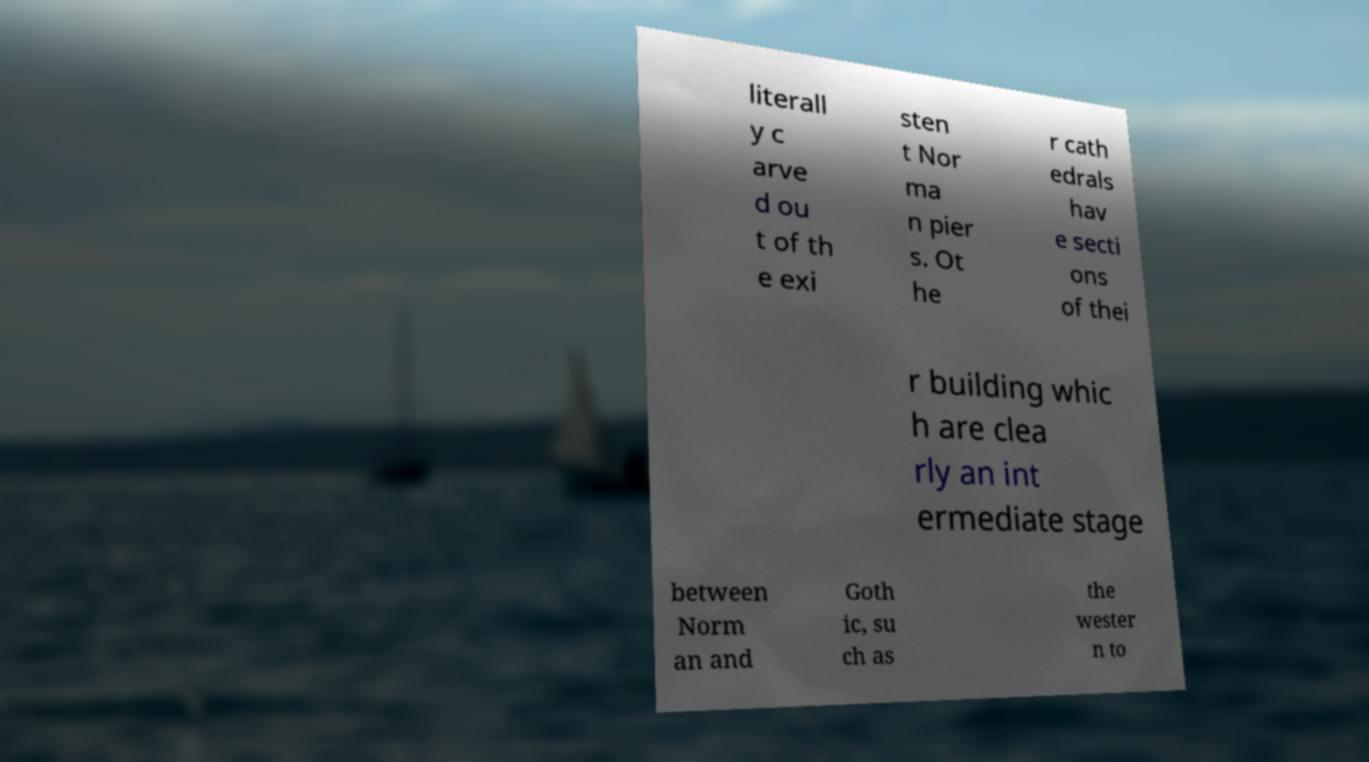Please identify and transcribe the text found in this image. literall y c arve d ou t of th e exi sten t Nor ma n pier s. Ot he r cath edrals hav e secti ons of thei r building whic h are clea rly an int ermediate stage between Norm an and Goth ic, su ch as the wester n to 